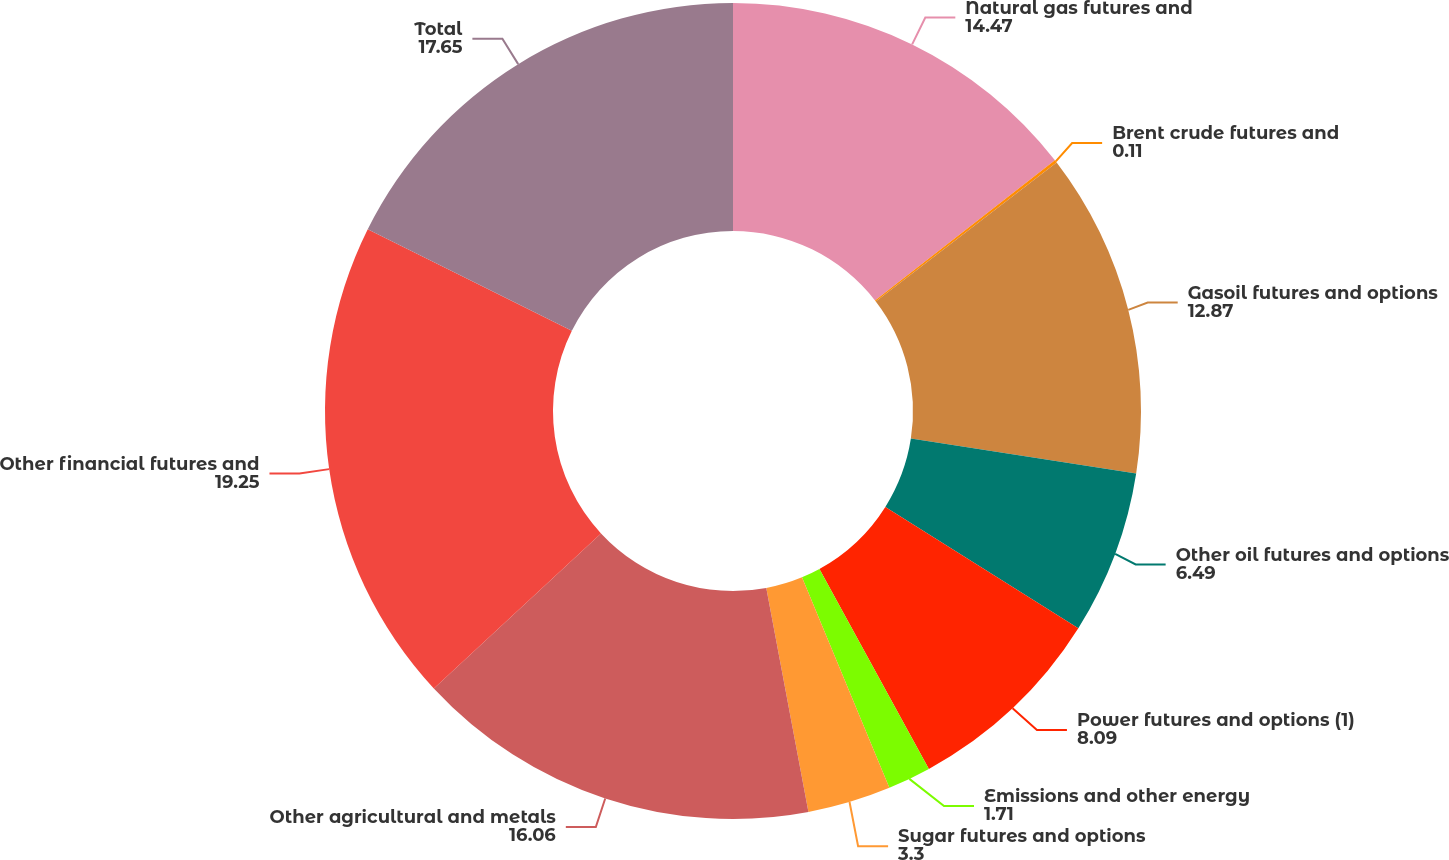<chart> <loc_0><loc_0><loc_500><loc_500><pie_chart><fcel>Natural gas futures and<fcel>Brent crude futures and<fcel>Gasoil futures and options<fcel>Other oil futures and options<fcel>Power futures and options (1)<fcel>Emissions and other energy<fcel>Sugar futures and options<fcel>Other agricultural and metals<fcel>Other financial futures and<fcel>Total<nl><fcel>14.47%<fcel>0.11%<fcel>12.87%<fcel>6.49%<fcel>8.09%<fcel>1.71%<fcel>3.3%<fcel>16.06%<fcel>19.25%<fcel>17.65%<nl></chart> 